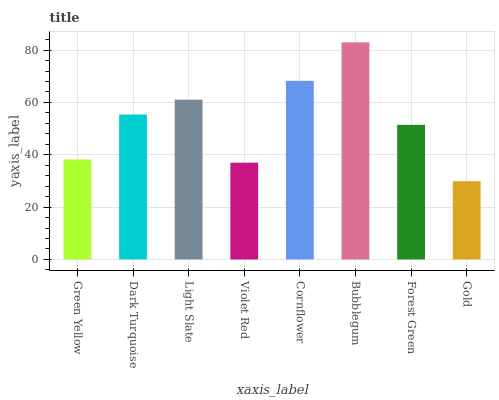Is Gold the minimum?
Answer yes or no. Yes. Is Bubblegum the maximum?
Answer yes or no. Yes. Is Dark Turquoise the minimum?
Answer yes or no. No. Is Dark Turquoise the maximum?
Answer yes or no. No. Is Dark Turquoise greater than Green Yellow?
Answer yes or no. Yes. Is Green Yellow less than Dark Turquoise?
Answer yes or no. Yes. Is Green Yellow greater than Dark Turquoise?
Answer yes or no. No. Is Dark Turquoise less than Green Yellow?
Answer yes or no. No. Is Dark Turquoise the high median?
Answer yes or no. Yes. Is Forest Green the low median?
Answer yes or no. Yes. Is Green Yellow the high median?
Answer yes or no. No. Is Dark Turquoise the low median?
Answer yes or no. No. 